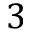Convert formula to latex. <formula><loc_0><loc_0><loc_500><loc_500>3</formula> 